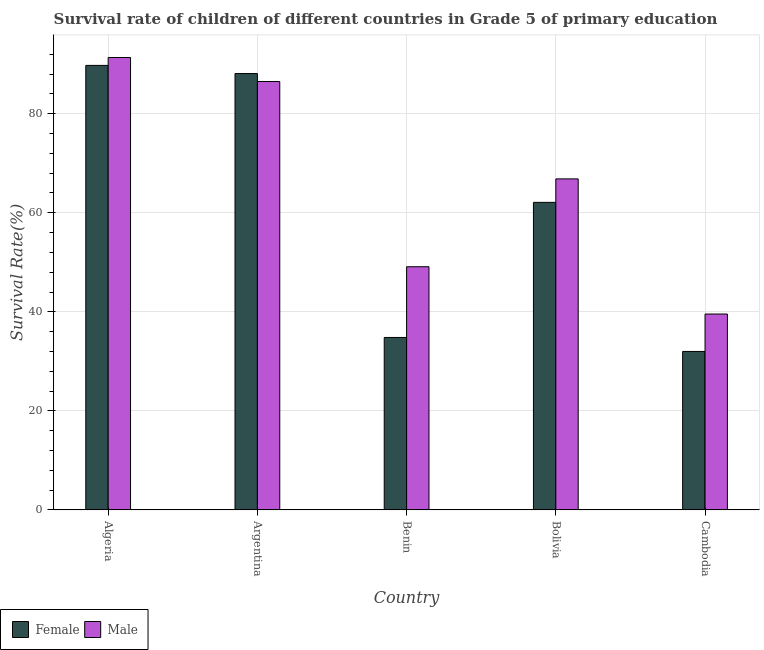How many groups of bars are there?
Ensure brevity in your answer.  5. Are the number of bars per tick equal to the number of legend labels?
Provide a succinct answer. Yes. What is the label of the 5th group of bars from the left?
Provide a short and direct response. Cambodia. What is the survival rate of male students in primary education in Argentina?
Provide a short and direct response. 86.5. Across all countries, what is the maximum survival rate of female students in primary education?
Give a very brief answer. 89.75. Across all countries, what is the minimum survival rate of male students in primary education?
Give a very brief answer. 39.55. In which country was the survival rate of female students in primary education maximum?
Ensure brevity in your answer.  Algeria. In which country was the survival rate of female students in primary education minimum?
Provide a succinct answer. Cambodia. What is the total survival rate of male students in primary education in the graph?
Give a very brief answer. 333.34. What is the difference between the survival rate of male students in primary education in Algeria and that in Bolivia?
Ensure brevity in your answer.  24.51. What is the difference between the survival rate of male students in primary education in Bolivia and the survival rate of female students in primary education in Algeria?
Provide a succinct answer. -22.91. What is the average survival rate of male students in primary education per country?
Ensure brevity in your answer.  66.67. What is the difference between the survival rate of male students in primary education and survival rate of female students in primary education in Bolivia?
Keep it short and to the point. 4.74. In how many countries, is the survival rate of male students in primary education greater than 12 %?
Offer a terse response. 5. What is the ratio of the survival rate of male students in primary education in Algeria to that in Cambodia?
Provide a succinct answer. 2.31. Is the difference between the survival rate of female students in primary education in Benin and Bolivia greater than the difference between the survival rate of male students in primary education in Benin and Bolivia?
Ensure brevity in your answer.  No. What is the difference between the highest and the second highest survival rate of female students in primary education?
Give a very brief answer. 1.64. What is the difference between the highest and the lowest survival rate of female students in primary education?
Provide a short and direct response. 57.75. In how many countries, is the survival rate of female students in primary education greater than the average survival rate of female students in primary education taken over all countries?
Provide a succinct answer. 3. Is the sum of the survival rate of male students in primary education in Algeria and Cambodia greater than the maximum survival rate of female students in primary education across all countries?
Your answer should be very brief. Yes. What does the 1st bar from the right in Cambodia represents?
Provide a short and direct response. Male. How many bars are there?
Ensure brevity in your answer.  10. Are all the bars in the graph horizontal?
Your answer should be very brief. No. How many countries are there in the graph?
Provide a succinct answer. 5. What is the difference between two consecutive major ticks on the Y-axis?
Your response must be concise. 20. Are the values on the major ticks of Y-axis written in scientific E-notation?
Your answer should be very brief. No. Does the graph contain grids?
Your answer should be compact. Yes. How are the legend labels stacked?
Make the answer very short. Horizontal. What is the title of the graph?
Your answer should be very brief. Survival rate of children of different countries in Grade 5 of primary education. Does "Research and Development" appear as one of the legend labels in the graph?
Your response must be concise. No. What is the label or title of the X-axis?
Give a very brief answer. Country. What is the label or title of the Y-axis?
Offer a terse response. Survival Rate(%). What is the Survival Rate(%) of Female in Algeria?
Offer a terse response. 89.75. What is the Survival Rate(%) of Male in Algeria?
Offer a very short reply. 91.35. What is the Survival Rate(%) in Female in Argentina?
Offer a very short reply. 88.11. What is the Survival Rate(%) in Male in Argentina?
Make the answer very short. 86.5. What is the Survival Rate(%) of Female in Benin?
Give a very brief answer. 34.82. What is the Survival Rate(%) of Male in Benin?
Your answer should be very brief. 49.1. What is the Survival Rate(%) in Female in Bolivia?
Give a very brief answer. 62.1. What is the Survival Rate(%) in Male in Bolivia?
Your answer should be very brief. 66.84. What is the Survival Rate(%) in Female in Cambodia?
Provide a short and direct response. 32. What is the Survival Rate(%) of Male in Cambodia?
Offer a terse response. 39.55. Across all countries, what is the maximum Survival Rate(%) of Female?
Make the answer very short. 89.75. Across all countries, what is the maximum Survival Rate(%) in Male?
Offer a terse response. 91.35. Across all countries, what is the minimum Survival Rate(%) in Female?
Offer a very short reply. 32. Across all countries, what is the minimum Survival Rate(%) in Male?
Your answer should be very brief. 39.55. What is the total Survival Rate(%) in Female in the graph?
Make the answer very short. 306.78. What is the total Survival Rate(%) in Male in the graph?
Your answer should be compact. 333.34. What is the difference between the Survival Rate(%) in Female in Algeria and that in Argentina?
Make the answer very short. 1.64. What is the difference between the Survival Rate(%) in Male in Algeria and that in Argentina?
Your answer should be compact. 4.85. What is the difference between the Survival Rate(%) of Female in Algeria and that in Benin?
Give a very brief answer. 54.93. What is the difference between the Survival Rate(%) of Male in Algeria and that in Benin?
Your answer should be very brief. 42.24. What is the difference between the Survival Rate(%) in Female in Algeria and that in Bolivia?
Your response must be concise. 27.65. What is the difference between the Survival Rate(%) in Male in Algeria and that in Bolivia?
Give a very brief answer. 24.51. What is the difference between the Survival Rate(%) in Female in Algeria and that in Cambodia?
Offer a very short reply. 57.75. What is the difference between the Survival Rate(%) of Male in Algeria and that in Cambodia?
Your answer should be compact. 51.79. What is the difference between the Survival Rate(%) in Female in Argentina and that in Benin?
Provide a short and direct response. 53.29. What is the difference between the Survival Rate(%) of Male in Argentina and that in Benin?
Provide a succinct answer. 37.39. What is the difference between the Survival Rate(%) of Female in Argentina and that in Bolivia?
Offer a terse response. 26.01. What is the difference between the Survival Rate(%) in Male in Argentina and that in Bolivia?
Offer a very short reply. 19.66. What is the difference between the Survival Rate(%) of Female in Argentina and that in Cambodia?
Make the answer very short. 56.11. What is the difference between the Survival Rate(%) in Male in Argentina and that in Cambodia?
Your response must be concise. 46.94. What is the difference between the Survival Rate(%) of Female in Benin and that in Bolivia?
Offer a very short reply. -27.28. What is the difference between the Survival Rate(%) of Male in Benin and that in Bolivia?
Make the answer very short. -17.73. What is the difference between the Survival Rate(%) of Female in Benin and that in Cambodia?
Offer a terse response. 2.82. What is the difference between the Survival Rate(%) of Male in Benin and that in Cambodia?
Offer a very short reply. 9.55. What is the difference between the Survival Rate(%) of Female in Bolivia and that in Cambodia?
Your answer should be very brief. 30.1. What is the difference between the Survival Rate(%) of Male in Bolivia and that in Cambodia?
Give a very brief answer. 27.29. What is the difference between the Survival Rate(%) of Female in Algeria and the Survival Rate(%) of Male in Argentina?
Offer a very short reply. 3.26. What is the difference between the Survival Rate(%) of Female in Algeria and the Survival Rate(%) of Male in Benin?
Give a very brief answer. 40.65. What is the difference between the Survival Rate(%) in Female in Algeria and the Survival Rate(%) in Male in Bolivia?
Offer a very short reply. 22.91. What is the difference between the Survival Rate(%) of Female in Algeria and the Survival Rate(%) of Male in Cambodia?
Your answer should be compact. 50.2. What is the difference between the Survival Rate(%) in Female in Argentina and the Survival Rate(%) in Male in Benin?
Ensure brevity in your answer.  39. What is the difference between the Survival Rate(%) in Female in Argentina and the Survival Rate(%) in Male in Bolivia?
Keep it short and to the point. 21.27. What is the difference between the Survival Rate(%) of Female in Argentina and the Survival Rate(%) of Male in Cambodia?
Make the answer very short. 48.55. What is the difference between the Survival Rate(%) of Female in Benin and the Survival Rate(%) of Male in Bolivia?
Give a very brief answer. -32.02. What is the difference between the Survival Rate(%) of Female in Benin and the Survival Rate(%) of Male in Cambodia?
Your response must be concise. -4.73. What is the difference between the Survival Rate(%) of Female in Bolivia and the Survival Rate(%) of Male in Cambodia?
Keep it short and to the point. 22.54. What is the average Survival Rate(%) in Female per country?
Provide a short and direct response. 61.36. What is the average Survival Rate(%) of Male per country?
Your answer should be very brief. 66.67. What is the difference between the Survival Rate(%) in Female and Survival Rate(%) in Male in Algeria?
Offer a very short reply. -1.59. What is the difference between the Survival Rate(%) of Female and Survival Rate(%) of Male in Argentina?
Provide a short and direct response. 1.61. What is the difference between the Survival Rate(%) in Female and Survival Rate(%) in Male in Benin?
Offer a terse response. -14.28. What is the difference between the Survival Rate(%) of Female and Survival Rate(%) of Male in Bolivia?
Provide a short and direct response. -4.74. What is the difference between the Survival Rate(%) of Female and Survival Rate(%) of Male in Cambodia?
Provide a succinct answer. -7.55. What is the ratio of the Survival Rate(%) of Female in Algeria to that in Argentina?
Offer a very short reply. 1.02. What is the ratio of the Survival Rate(%) of Male in Algeria to that in Argentina?
Ensure brevity in your answer.  1.06. What is the ratio of the Survival Rate(%) of Female in Algeria to that in Benin?
Offer a terse response. 2.58. What is the ratio of the Survival Rate(%) in Male in Algeria to that in Benin?
Offer a very short reply. 1.86. What is the ratio of the Survival Rate(%) of Female in Algeria to that in Bolivia?
Keep it short and to the point. 1.45. What is the ratio of the Survival Rate(%) in Male in Algeria to that in Bolivia?
Give a very brief answer. 1.37. What is the ratio of the Survival Rate(%) in Female in Algeria to that in Cambodia?
Make the answer very short. 2.8. What is the ratio of the Survival Rate(%) in Male in Algeria to that in Cambodia?
Keep it short and to the point. 2.31. What is the ratio of the Survival Rate(%) in Female in Argentina to that in Benin?
Your answer should be very brief. 2.53. What is the ratio of the Survival Rate(%) in Male in Argentina to that in Benin?
Your answer should be very brief. 1.76. What is the ratio of the Survival Rate(%) in Female in Argentina to that in Bolivia?
Keep it short and to the point. 1.42. What is the ratio of the Survival Rate(%) of Male in Argentina to that in Bolivia?
Your answer should be compact. 1.29. What is the ratio of the Survival Rate(%) of Female in Argentina to that in Cambodia?
Provide a succinct answer. 2.75. What is the ratio of the Survival Rate(%) in Male in Argentina to that in Cambodia?
Ensure brevity in your answer.  2.19. What is the ratio of the Survival Rate(%) of Female in Benin to that in Bolivia?
Provide a short and direct response. 0.56. What is the ratio of the Survival Rate(%) in Male in Benin to that in Bolivia?
Your answer should be very brief. 0.73. What is the ratio of the Survival Rate(%) of Female in Benin to that in Cambodia?
Your response must be concise. 1.09. What is the ratio of the Survival Rate(%) in Male in Benin to that in Cambodia?
Your answer should be compact. 1.24. What is the ratio of the Survival Rate(%) in Female in Bolivia to that in Cambodia?
Ensure brevity in your answer.  1.94. What is the ratio of the Survival Rate(%) of Male in Bolivia to that in Cambodia?
Your answer should be compact. 1.69. What is the difference between the highest and the second highest Survival Rate(%) of Female?
Your answer should be compact. 1.64. What is the difference between the highest and the second highest Survival Rate(%) of Male?
Make the answer very short. 4.85. What is the difference between the highest and the lowest Survival Rate(%) in Female?
Your response must be concise. 57.75. What is the difference between the highest and the lowest Survival Rate(%) in Male?
Give a very brief answer. 51.79. 